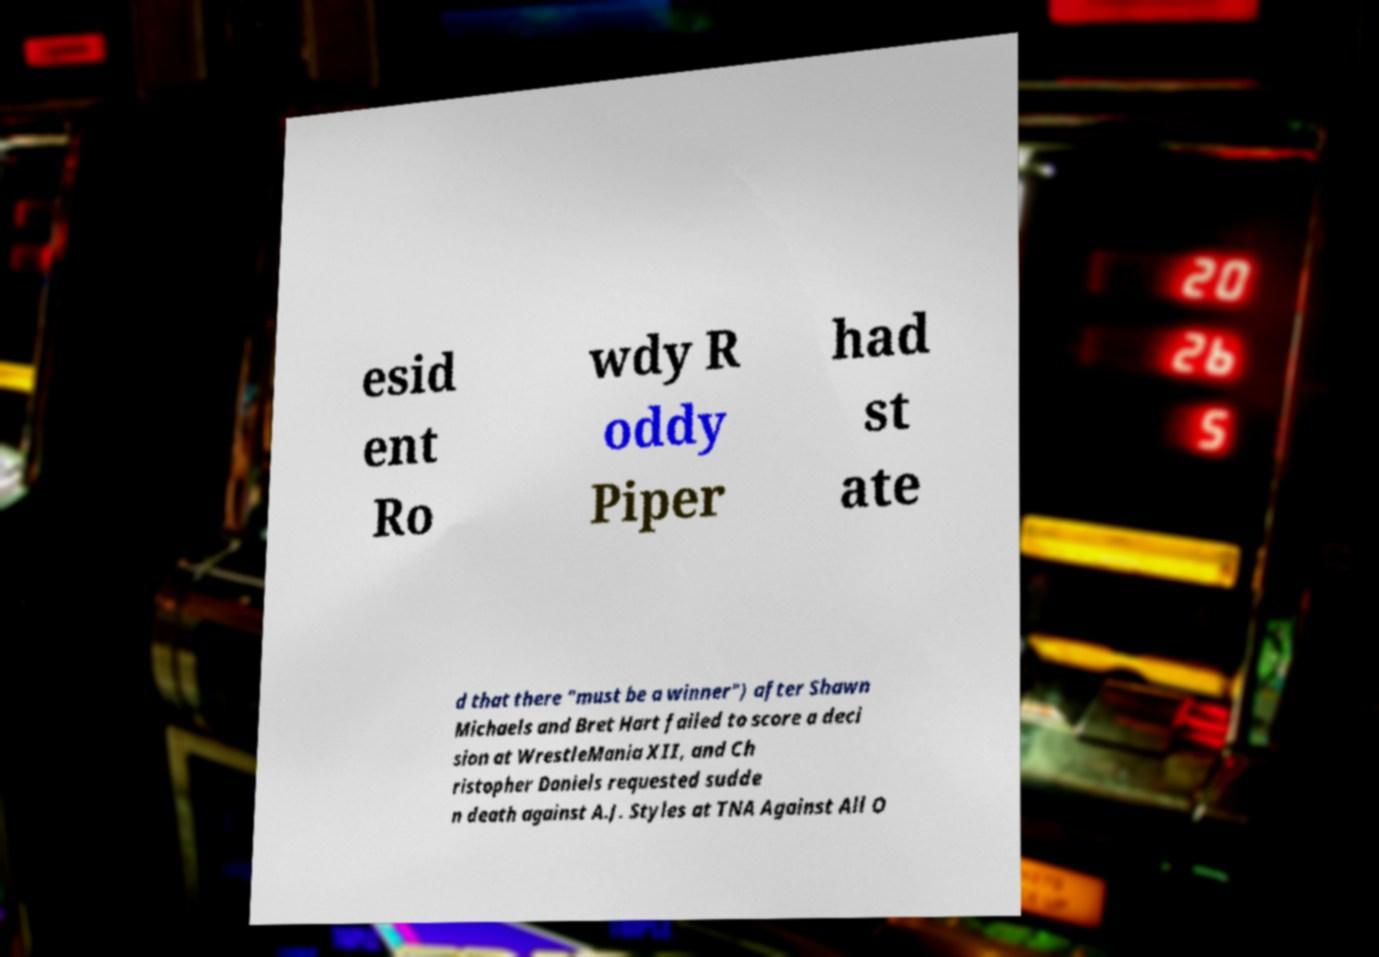Please identify and transcribe the text found in this image. esid ent Ro wdy R oddy Piper had st ate d that there "must be a winner") after Shawn Michaels and Bret Hart failed to score a deci sion at WrestleMania XII, and Ch ristopher Daniels requested sudde n death against A.J. Styles at TNA Against All O 